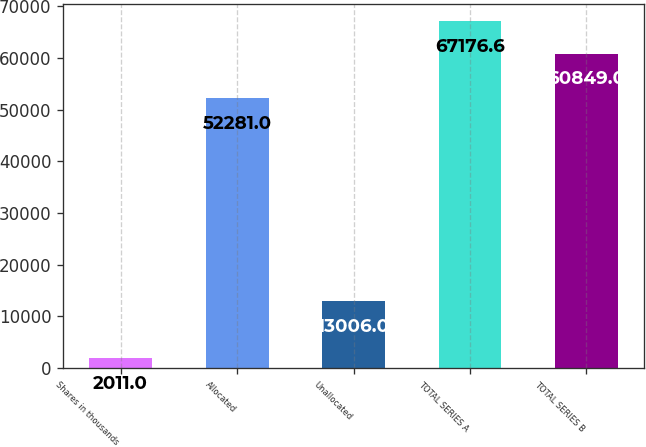<chart> <loc_0><loc_0><loc_500><loc_500><bar_chart><fcel>Shares in thousands<fcel>Allocated<fcel>Unallocated<fcel>TOTAL SERIES A<fcel>TOTAL SERIES B<nl><fcel>2011<fcel>52281<fcel>13006<fcel>67176.6<fcel>60849<nl></chart> 